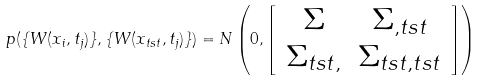Convert formula to latex. <formula><loc_0><loc_0><loc_500><loc_500>p ( \{ W ( x _ { i } , t _ { j } ) \} , \{ W ( x _ { t s t } , t _ { j } ) \} ) = N \left ( 0 , \left [ \begin{array} { c c } \Sigma & \Sigma _ { , t s t } \\ \Sigma _ { t s t , } & \Sigma _ { t s t , t s t } \end{array} \right ] \right )</formula> 